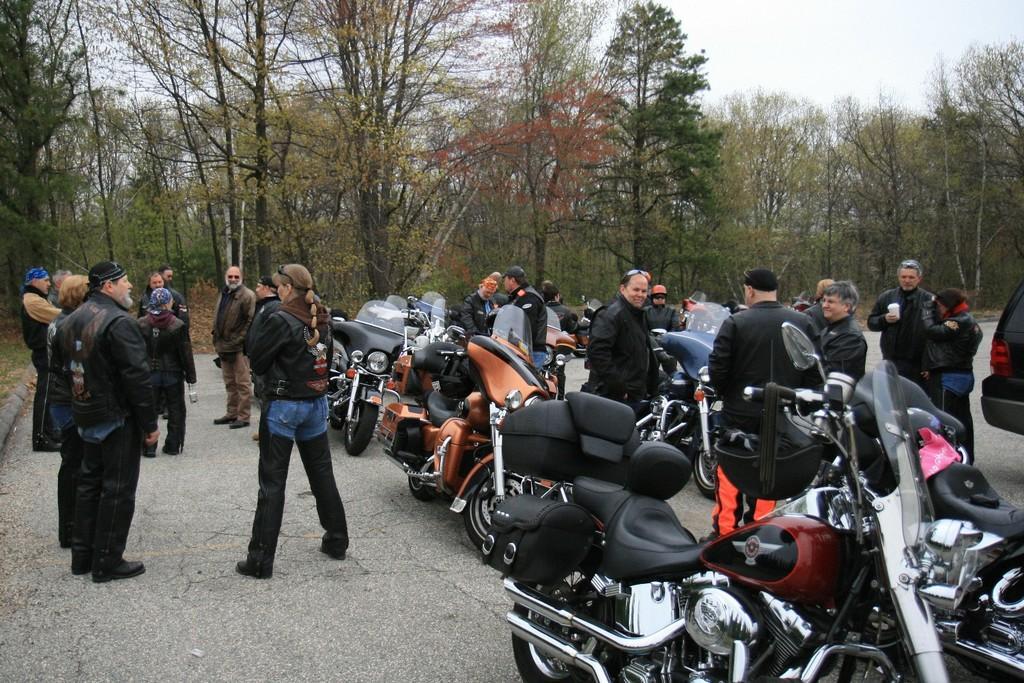How would you summarize this image in a sentence or two? In this image we can see many people. Some are wearing caps. Also there are motorcycles. In the background there are trees. And also there is sky. 